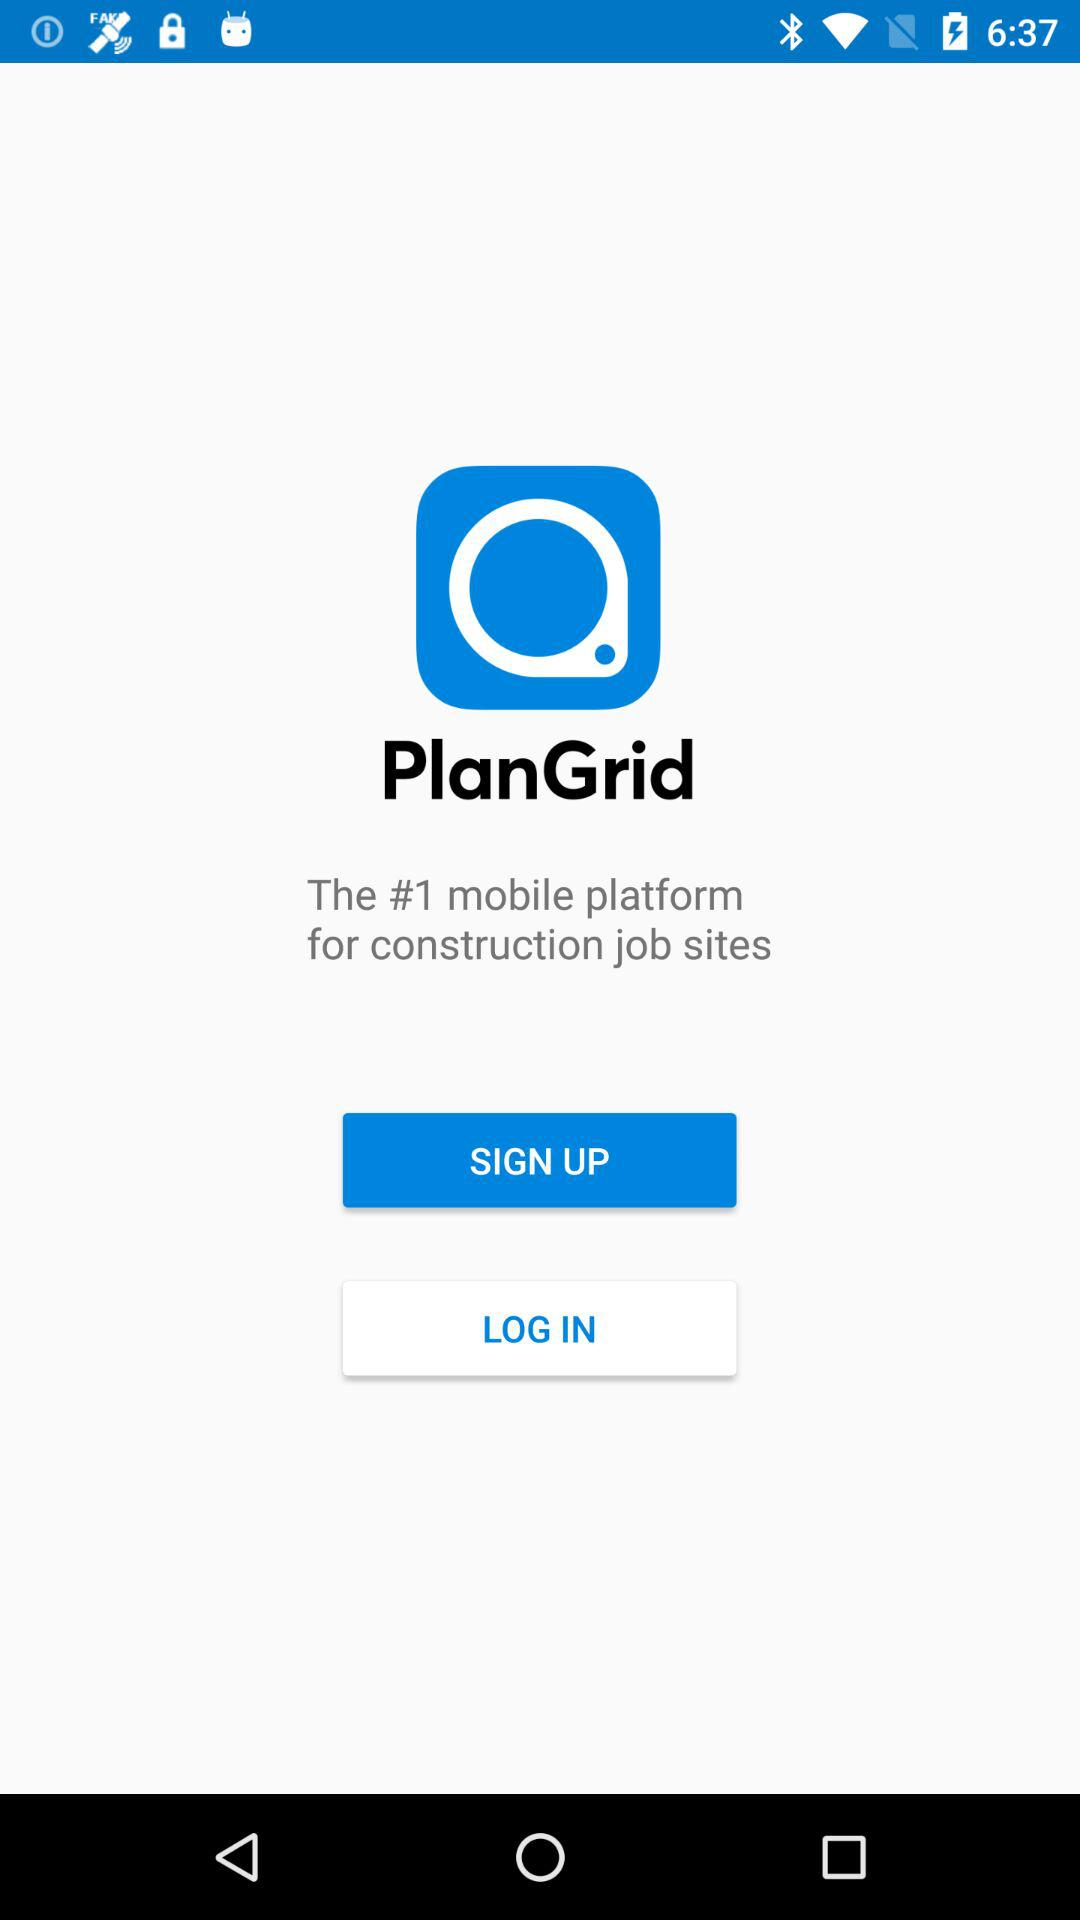What is the application name? The application name is "PlanGrid". 